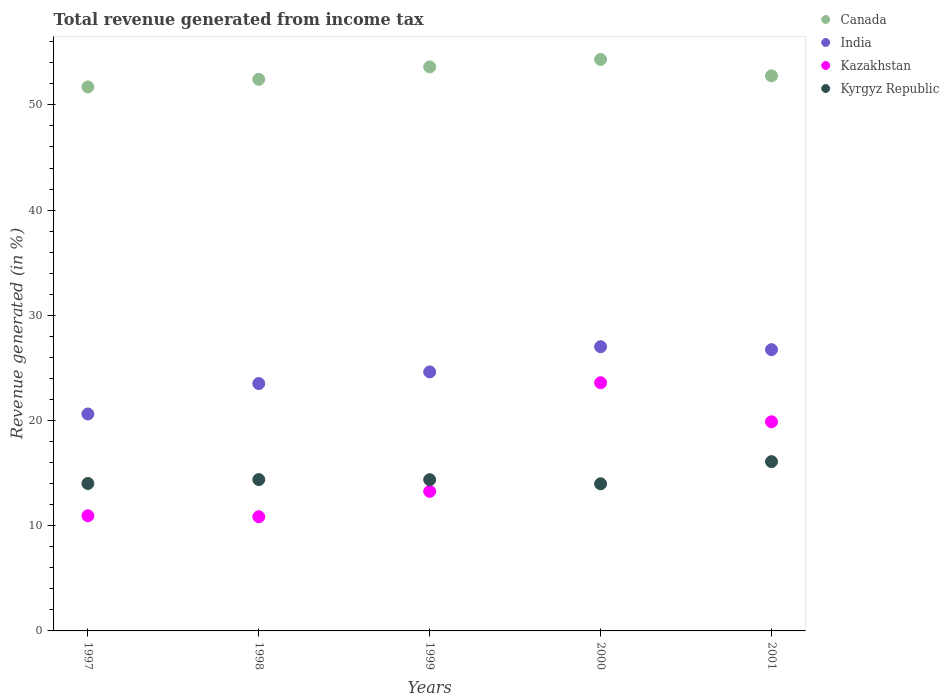How many different coloured dotlines are there?
Your response must be concise. 4. Is the number of dotlines equal to the number of legend labels?
Your answer should be very brief. Yes. What is the total revenue generated in Kazakhstan in 1997?
Provide a succinct answer. 10.95. Across all years, what is the maximum total revenue generated in India?
Offer a terse response. 27.01. Across all years, what is the minimum total revenue generated in Canada?
Your response must be concise. 51.71. In which year was the total revenue generated in Kazakhstan minimum?
Make the answer very short. 1998. What is the total total revenue generated in India in the graph?
Offer a very short reply. 122.5. What is the difference between the total revenue generated in Kyrgyz Republic in 1997 and that in 2001?
Give a very brief answer. -2.08. What is the difference between the total revenue generated in Kyrgyz Republic in 2000 and the total revenue generated in Kazakhstan in 2001?
Your answer should be compact. -5.89. What is the average total revenue generated in Canada per year?
Give a very brief answer. 52.97. In the year 1998, what is the difference between the total revenue generated in India and total revenue generated in Kyrgyz Republic?
Offer a very short reply. 9.13. What is the ratio of the total revenue generated in India in 1997 to that in 1998?
Your response must be concise. 0.88. Is the total revenue generated in Canada in 1997 less than that in 2000?
Keep it short and to the point. Yes. What is the difference between the highest and the second highest total revenue generated in Kyrgyz Republic?
Your answer should be very brief. 1.71. What is the difference between the highest and the lowest total revenue generated in Kazakhstan?
Keep it short and to the point. 12.74. Is the sum of the total revenue generated in India in 1997 and 2001 greater than the maximum total revenue generated in Kazakhstan across all years?
Make the answer very short. Yes. Is it the case that in every year, the sum of the total revenue generated in Kyrgyz Republic and total revenue generated in India  is greater than the total revenue generated in Kazakhstan?
Offer a terse response. Yes. Does the total revenue generated in India monotonically increase over the years?
Give a very brief answer. No. How many dotlines are there?
Your answer should be very brief. 4. What is the difference between two consecutive major ticks on the Y-axis?
Offer a very short reply. 10. Are the values on the major ticks of Y-axis written in scientific E-notation?
Keep it short and to the point. No. Does the graph contain grids?
Give a very brief answer. No. How many legend labels are there?
Ensure brevity in your answer.  4. How are the legend labels stacked?
Your answer should be very brief. Vertical. What is the title of the graph?
Make the answer very short. Total revenue generated from income tax. Does "Sierra Leone" appear as one of the legend labels in the graph?
Keep it short and to the point. No. What is the label or title of the X-axis?
Your answer should be very brief. Years. What is the label or title of the Y-axis?
Keep it short and to the point. Revenue generated (in %). What is the Revenue generated (in %) in Canada in 1997?
Your answer should be very brief. 51.71. What is the Revenue generated (in %) in India in 1997?
Your answer should be very brief. 20.62. What is the Revenue generated (in %) of Kazakhstan in 1997?
Ensure brevity in your answer.  10.95. What is the Revenue generated (in %) in Kyrgyz Republic in 1997?
Make the answer very short. 14.01. What is the Revenue generated (in %) of Canada in 1998?
Give a very brief answer. 52.43. What is the Revenue generated (in %) of India in 1998?
Provide a short and direct response. 23.51. What is the Revenue generated (in %) in Kazakhstan in 1998?
Give a very brief answer. 10.85. What is the Revenue generated (in %) in Kyrgyz Republic in 1998?
Keep it short and to the point. 14.39. What is the Revenue generated (in %) in Canada in 1999?
Provide a succinct answer. 53.61. What is the Revenue generated (in %) of India in 1999?
Make the answer very short. 24.62. What is the Revenue generated (in %) in Kazakhstan in 1999?
Provide a succinct answer. 13.26. What is the Revenue generated (in %) of Kyrgyz Republic in 1999?
Your answer should be compact. 14.38. What is the Revenue generated (in %) of Canada in 2000?
Give a very brief answer. 54.32. What is the Revenue generated (in %) in India in 2000?
Your response must be concise. 27.01. What is the Revenue generated (in %) of Kazakhstan in 2000?
Give a very brief answer. 23.59. What is the Revenue generated (in %) of Kyrgyz Republic in 2000?
Your response must be concise. 13.98. What is the Revenue generated (in %) of Canada in 2001?
Offer a very short reply. 52.76. What is the Revenue generated (in %) of India in 2001?
Make the answer very short. 26.73. What is the Revenue generated (in %) in Kazakhstan in 2001?
Give a very brief answer. 19.88. What is the Revenue generated (in %) of Kyrgyz Republic in 2001?
Provide a short and direct response. 16.09. Across all years, what is the maximum Revenue generated (in %) in Canada?
Your answer should be compact. 54.32. Across all years, what is the maximum Revenue generated (in %) in India?
Your answer should be very brief. 27.01. Across all years, what is the maximum Revenue generated (in %) in Kazakhstan?
Offer a very short reply. 23.59. Across all years, what is the maximum Revenue generated (in %) of Kyrgyz Republic?
Provide a short and direct response. 16.09. Across all years, what is the minimum Revenue generated (in %) in Canada?
Your answer should be compact. 51.71. Across all years, what is the minimum Revenue generated (in %) of India?
Offer a very short reply. 20.62. Across all years, what is the minimum Revenue generated (in %) of Kazakhstan?
Make the answer very short. 10.85. Across all years, what is the minimum Revenue generated (in %) of Kyrgyz Republic?
Your answer should be very brief. 13.98. What is the total Revenue generated (in %) in Canada in the graph?
Give a very brief answer. 264.83. What is the total Revenue generated (in %) of India in the graph?
Give a very brief answer. 122.5. What is the total Revenue generated (in %) of Kazakhstan in the graph?
Provide a succinct answer. 78.53. What is the total Revenue generated (in %) of Kyrgyz Republic in the graph?
Provide a short and direct response. 72.85. What is the difference between the Revenue generated (in %) in Canada in 1997 and that in 1998?
Your answer should be very brief. -0.72. What is the difference between the Revenue generated (in %) in India in 1997 and that in 1998?
Give a very brief answer. -2.89. What is the difference between the Revenue generated (in %) of Kazakhstan in 1997 and that in 1998?
Offer a terse response. 0.09. What is the difference between the Revenue generated (in %) of Kyrgyz Republic in 1997 and that in 1998?
Provide a short and direct response. -0.37. What is the difference between the Revenue generated (in %) in Canada in 1997 and that in 1999?
Provide a short and direct response. -1.9. What is the difference between the Revenue generated (in %) in India in 1997 and that in 1999?
Your answer should be compact. -4. What is the difference between the Revenue generated (in %) of Kazakhstan in 1997 and that in 1999?
Provide a succinct answer. -2.32. What is the difference between the Revenue generated (in %) of Kyrgyz Republic in 1997 and that in 1999?
Offer a terse response. -0.36. What is the difference between the Revenue generated (in %) in Canada in 1997 and that in 2000?
Your response must be concise. -2.61. What is the difference between the Revenue generated (in %) in India in 1997 and that in 2000?
Provide a short and direct response. -6.39. What is the difference between the Revenue generated (in %) of Kazakhstan in 1997 and that in 2000?
Ensure brevity in your answer.  -12.65. What is the difference between the Revenue generated (in %) of Kyrgyz Republic in 1997 and that in 2000?
Make the answer very short. 0.03. What is the difference between the Revenue generated (in %) in Canada in 1997 and that in 2001?
Keep it short and to the point. -1.05. What is the difference between the Revenue generated (in %) of India in 1997 and that in 2001?
Your answer should be very brief. -6.11. What is the difference between the Revenue generated (in %) of Kazakhstan in 1997 and that in 2001?
Your answer should be very brief. -8.93. What is the difference between the Revenue generated (in %) in Kyrgyz Republic in 1997 and that in 2001?
Provide a short and direct response. -2.08. What is the difference between the Revenue generated (in %) of Canada in 1998 and that in 1999?
Your answer should be compact. -1.18. What is the difference between the Revenue generated (in %) of India in 1998 and that in 1999?
Your answer should be compact. -1.11. What is the difference between the Revenue generated (in %) of Kazakhstan in 1998 and that in 1999?
Make the answer very short. -2.41. What is the difference between the Revenue generated (in %) in Kyrgyz Republic in 1998 and that in 1999?
Your answer should be very brief. 0.01. What is the difference between the Revenue generated (in %) of Canada in 1998 and that in 2000?
Your response must be concise. -1.89. What is the difference between the Revenue generated (in %) of India in 1998 and that in 2000?
Provide a short and direct response. -3.5. What is the difference between the Revenue generated (in %) in Kazakhstan in 1998 and that in 2000?
Make the answer very short. -12.74. What is the difference between the Revenue generated (in %) of Kyrgyz Republic in 1998 and that in 2000?
Provide a short and direct response. 0.4. What is the difference between the Revenue generated (in %) of Canada in 1998 and that in 2001?
Offer a terse response. -0.33. What is the difference between the Revenue generated (in %) of India in 1998 and that in 2001?
Make the answer very short. -3.22. What is the difference between the Revenue generated (in %) in Kazakhstan in 1998 and that in 2001?
Your answer should be compact. -9.02. What is the difference between the Revenue generated (in %) in Kyrgyz Republic in 1998 and that in 2001?
Keep it short and to the point. -1.71. What is the difference between the Revenue generated (in %) of Canada in 1999 and that in 2000?
Your answer should be very brief. -0.71. What is the difference between the Revenue generated (in %) of India in 1999 and that in 2000?
Your answer should be compact. -2.4. What is the difference between the Revenue generated (in %) in Kazakhstan in 1999 and that in 2000?
Provide a succinct answer. -10.33. What is the difference between the Revenue generated (in %) of Kyrgyz Republic in 1999 and that in 2000?
Make the answer very short. 0.39. What is the difference between the Revenue generated (in %) in Canada in 1999 and that in 2001?
Provide a short and direct response. 0.85. What is the difference between the Revenue generated (in %) in India in 1999 and that in 2001?
Provide a succinct answer. -2.12. What is the difference between the Revenue generated (in %) in Kazakhstan in 1999 and that in 2001?
Offer a terse response. -6.61. What is the difference between the Revenue generated (in %) in Kyrgyz Republic in 1999 and that in 2001?
Your answer should be very brief. -1.72. What is the difference between the Revenue generated (in %) in Canada in 2000 and that in 2001?
Your answer should be very brief. 1.56. What is the difference between the Revenue generated (in %) in India in 2000 and that in 2001?
Your response must be concise. 0.28. What is the difference between the Revenue generated (in %) in Kazakhstan in 2000 and that in 2001?
Provide a succinct answer. 3.71. What is the difference between the Revenue generated (in %) in Kyrgyz Republic in 2000 and that in 2001?
Provide a succinct answer. -2.11. What is the difference between the Revenue generated (in %) of Canada in 1997 and the Revenue generated (in %) of India in 1998?
Offer a very short reply. 28.2. What is the difference between the Revenue generated (in %) in Canada in 1997 and the Revenue generated (in %) in Kazakhstan in 1998?
Your answer should be very brief. 40.86. What is the difference between the Revenue generated (in %) in Canada in 1997 and the Revenue generated (in %) in Kyrgyz Republic in 1998?
Offer a very short reply. 37.32. What is the difference between the Revenue generated (in %) in India in 1997 and the Revenue generated (in %) in Kazakhstan in 1998?
Keep it short and to the point. 9.77. What is the difference between the Revenue generated (in %) of India in 1997 and the Revenue generated (in %) of Kyrgyz Republic in 1998?
Offer a terse response. 6.24. What is the difference between the Revenue generated (in %) in Kazakhstan in 1997 and the Revenue generated (in %) in Kyrgyz Republic in 1998?
Provide a succinct answer. -3.44. What is the difference between the Revenue generated (in %) of Canada in 1997 and the Revenue generated (in %) of India in 1999?
Make the answer very short. 27.09. What is the difference between the Revenue generated (in %) in Canada in 1997 and the Revenue generated (in %) in Kazakhstan in 1999?
Make the answer very short. 38.44. What is the difference between the Revenue generated (in %) in Canada in 1997 and the Revenue generated (in %) in Kyrgyz Republic in 1999?
Provide a short and direct response. 37.33. What is the difference between the Revenue generated (in %) in India in 1997 and the Revenue generated (in %) in Kazakhstan in 1999?
Provide a succinct answer. 7.36. What is the difference between the Revenue generated (in %) of India in 1997 and the Revenue generated (in %) of Kyrgyz Republic in 1999?
Provide a succinct answer. 6.25. What is the difference between the Revenue generated (in %) in Kazakhstan in 1997 and the Revenue generated (in %) in Kyrgyz Republic in 1999?
Your answer should be very brief. -3.43. What is the difference between the Revenue generated (in %) of Canada in 1997 and the Revenue generated (in %) of India in 2000?
Offer a terse response. 24.7. What is the difference between the Revenue generated (in %) in Canada in 1997 and the Revenue generated (in %) in Kazakhstan in 2000?
Your answer should be compact. 28.12. What is the difference between the Revenue generated (in %) of Canada in 1997 and the Revenue generated (in %) of Kyrgyz Republic in 2000?
Offer a terse response. 37.73. What is the difference between the Revenue generated (in %) in India in 1997 and the Revenue generated (in %) in Kazakhstan in 2000?
Ensure brevity in your answer.  -2.97. What is the difference between the Revenue generated (in %) in India in 1997 and the Revenue generated (in %) in Kyrgyz Republic in 2000?
Make the answer very short. 6.64. What is the difference between the Revenue generated (in %) in Kazakhstan in 1997 and the Revenue generated (in %) in Kyrgyz Republic in 2000?
Provide a succinct answer. -3.04. What is the difference between the Revenue generated (in %) of Canada in 1997 and the Revenue generated (in %) of India in 2001?
Provide a succinct answer. 24.98. What is the difference between the Revenue generated (in %) of Canada in 1997 and the Revenue generated (in %) of Kazakhstan in 2001?
Ensure brevity in your answer.  31.83. What is the difference between the Revenue generated (in %) in Canada in 1997 and the Revenue generated (in %) in Kyrgyz Republic in 2001?
Offer a terse response. 35.62. What is the difference between the Revenue generated (in %) of India in 1997 and the Revenue generated (in %) of Kazakhstan in 2001?
Make the answer very short. 0.74. What is the difference between the Revenue generated (in %) of India in 1997 and the Revenue generated (in %) of Kyrgyz Republic in 2001?
Provide a short and direct response. 4.53. What is the difference between the Revenue generated (in %) of Kazakhstan in 1997 and the Revenue generated (in %) of Kyrgyz Republic in 2001?
Provide a succinct answer. -5.14. What is the difference between the Revenue generated (in %) of Canada in 1998 and the Revenue generated (in %) of India in 1999?
Offer a terse response. 27.81. What is the difference between the Revenue generated (in %) in Canada in 1998 and the Revenue generated (in %) in Kazakhstan in 1999?
Your response must be concise. 39.17. What is the difference between the Revenue generated (in %) of Canada in 1998 and the Revenue generated (in %) of Kyrgyz Republic in 1999?
Give a very brief answer. 38.06. What is the difference between the Revenue generated (in %) in India in 1998 and the Revenue generated (in %) in Kazakhstan in 1999?
Your response must be concise. 10.25. What is the difference between the Revenue generated (in %) in India in 1998 and the Revenue generated (in %) in Kyrgyz Republic in 1999?
Give a very brief answer. 9.14. What is the difference between the Revenue generated (in %) in Kazakhstan in 1998 and the Revenue generated (in %) in Kyrgyz Republic in 1999?
Make the answer very short. -3.52. What is the difference between the Revenue generated (in %) in Canada in 1998 and the Revenue generated (in %) in India in 2000?
Provide a short and direct response. 25.42. What is the difference between the Revenue generated (in %) in Canada in 1998 and the Revenue generated (in %) in Kazakhstan in 2000?
Offer a very short reply. 28.84. What is the difference between the Revenue generated (in %) in Canada in 1998 and the Revenue generated (in %) in Kyrgyz Republic in 2000?
Provide a short and direct response. 38.45. What is the difference between the Revenue generated (in %) of India in 1998 and the Revenue generated (in %) of Kazakhstan in 2000?
Provide a succinct answer. -0.08. What is the difference between the Revenue generated (in %) in India in 1998 and the Revenue generated (in %) in Kyrgyz Republic in 2000?
Give a very brief answer. 9.53. What is the difference between the Revenue generated (in %) of Kazakhstan in 1998 and the Revenue generated (in %) of Kyrgyz Republic in 2000?
Provide a short and direct response. -3.13. What is the difference between the Revenue generated (in %) in Canada in 1998 and the Revenue generated (in %) in India in 2001?
Make the answer very short. 25.7. What is the difference between the Revenue generated (in %) of Canada in 1998 and the Revenue generated (in %) of Kazakhstan in 2001?
Give a very brief answer. 32.55. What is the difference between the Revenue generated (in %) in Canada in 1998 and the Revenue generated (in %) in Kyrgyz Republic in 2001?
Your answer should be compact. 36.34. What is the difference between the Revenue generated (in %) of India in 1998 and the Revenue generated (in %) of Kazakhstan in 2001?
Provide a short and direct response. 3.64. What is the difference between the Revenue generated (in %) of India in 1998 and the Revenue generated (in %) of Kyrgyz Republic in 2001?
Your answer should be very brief. 7.42. What is the difference between the Revenue generated (in %) of Kazakhstan in 1998 and the Revenue generated (in %) of Kyrgyz Republic in 2001?
Give a very brief answer. -5.24. What is the difference between the Revenue generated (in %) in Canada in 1999 and the Revenue generated (in %) in India in 2000?
Keep it short and to the point. 26.6. What is the difference between the Revenue generated (in %) of Canada in 1999 and the Revenue generated (in %) of Kazakhstan in 2000?
Keep it short and to the point. 30.02. What is the difference between the Revenue generated (in %) of Canada in 1999 and the Revenue generated (in %) of Kyrgyz Republic in 2000?
Offer a very short reply. 39.63. What is the difference between the Revenue generated (in %) in India in 1999 and the Revenue generated (in %) in Kazakhstan in 2000?
Keep it short and to the point. 1.03. What is the difference between the Revenue generated (in %) of India in 1999 and the Revenue generated (in %) of Kyrgyz Republic in 2000?
Give a very brief answer. 10.63. What is the difference between the Revenue generated (in %) of Kazakhstan in 1999 and the Revenue generated (in %) of Kyrgyz Republic in 2000?
Your answer should be compact. -0.72. What is the difference between the Revenue generated (in %) in Canada in 1999 and the Revenue generated (in %) in India in 2001?
Your answer should be compact. 26.88. What is the difference between the Revenue generated (in %) of Canada in 1999 and the Revenue generated (in %) of Kazakhstan in 2001?
Offer a very short reply. 33.73. What is the difference between the Revenue generated (in %) of Canada in 1999 and the Revenue generated (in %) of Kyrgyz Republic in 2001?
Offer a very short reply. 37.52. What is the difference between the Revenue generated (in %) of India in 1999 and the Revenue generated (in %) of Kazakhstan in 2001?
Ensure brevity in your answer.  4.74. What is the difference between the Revenue generated (in %) of India in 1999 and the Revenue generated (in %) of Kyrgyz Republic in 2001?
Give a very brief answer. 8.53. What is the difference between the Revenue generated (in %) of Kazakhstan in 1999 and the Revenue generated (in %) of Kyrgyz Republic in 2001?
Ensure brevity in your answer.  -2.83. What is the difference between the Revenue generated (in %) of Canada in 2000 and the Revenue generated (in %) of India in 2001?
Ensure brevity in your answer.  27.59. What is the difference between the Revenue generated (in %) of Canada in 2000 and the Revenue generated (in %) of Kazakhstan in 2001?
Your response must be concise. 34.44. What is the difference between the Revenue generated (in %) of Canada in 2000 and the Revenue generated (in %) of Kyrgyz Republic in 2001?
Keep it short and to the point. 38.23. What is the difference between the Revenue generated (in %) of India in 2000 and the Revenue generated (in %) of Kazakhstan in 2001?
Offer a terse response. 7.14. What is the difference between the Revenue generated (in %) of India in 2000 and the Revenue generated (in %) of Kyrgyz Republic in 2001?
Provide a succinct answer. 10.92. What is the difference between the Revenue generated (in %) in Kazakhstan in 2000 and the Revenue generated (in %) in Kyrgyz Republic in 2001?
Make the answer very short. 7.5. What is the average Revenue generated (in %) of Canada per year?
Your response must be concise. 52.97. What is the average Revenue generated (in %) of India per year?
Offer a very short reply. 24.5. What is the average Revenue generated (in %) in Kazakhstan per year?
Your answer should be very brief. 15.71. What is the average Revenue generated (in %) in Kyrgyz Republic per year?
Offer a very short reply. 14.57. In the year 1997, what is the difference between the Revenue generated (in %) in Canada and Revenue generated (in %) in India?
Ensure brevity in your answer.  31.09. In the year 1997, what is the difference between the Revenue generated (in %) in Canada and Revenue generated (in %) in Kazakhstan?
Offer a very short reply. 40.76. In the year 1997, what is the difference between the Revenue generated (in %) in Canada and Revenue generated (in %) in Kyrgyz Republic?
Ensure brevity in your answer.  37.7. In the year 1997, what is the difference between the Revenue generated (in %) of India and Revenue generated (in %) of Kazakhstan?
Make the answer very short. 9.68. In the year 1997, what is the difference between the Revenue generated (in %) of India and Revenue generated (in %) of Kyrgyz Republic?
Provide a short and direct response. 6.61. In the year 1997, what is the difference between the Revenue generated (in %) of Kazakhstan and Revenue generated (in %) of Kyrgyz Republic?
Offer a very short reply. -3.07. In the year 1998, what is the difference between the Revenue generated (in %) in Canada and Revenue generated (in %) in India?
Provide a short and direct response. 28.92. In the year 1998, what is the difference between the Revenue generated (in %) of Canada and Revenue generated (in %) of Kazakhstan?
Keep it short and to the point. 41.58. In the year 1998, what is the difference between the Revenue generated (in %) of Canada and Revenue generated (in %) of Kyrgyz Republic?
Offer a very short reply. 38.05. In the year 1998, what is the difference between the Revenue generated (in %) in India and Revenue generated (in %) in Kazakhstan?
Make the answer very short. 12.66. In the year 1998, what is the difference between the Revenue generated (in %) of India and Revenue generated (in %) of Kyrgyz Republic?
Provide a short and direct response. 9.13. In the year 1998, what is the difference between the Revenue generated (in %) in Kazakhstan and Revenue generated (in %) in Kyrgyz Republic?
Provide a short and direct response. -3.53. In the year 1999, what is the difference between the Revenue generated (in %) in Canada and Revenue generated (in %) in India?
Provide a succinct answer. 28.99. In the year 1999, what is the difference between the Revenue generated (in %) of Canada and Revenue generated (in %) of Kazakhstan?
Make the answer very short. 40.35. In the year 1999, what is the difference between the Revenue generated (in %) in Canada and Revenue generated (in %) in Kyrgyz Republic?
Offer a terse response. 39.24. In the year 1999, what is the difference between the Revenue generated (in %) in India and Revenue generated (in %) in Kazakhstan?
Offer a terse response. 11.35. In the year 1999, what is the difference between the Revenue generated (in %) of India and Revenue generated (in %) of Kyrgyz Republic?
Provide a succinct answer. 10.24. In the year 1999, what is the difference between the Revenue generated (in %) in Kazakhstan and Revenue generated (in %) in Kyrgyz Republic?
Provide a succinct answer. -1.11. In the year 2000, what is the difference between the Revenue generated (in %) of Canada and Revenue generated (in %) of India?
Offer a very short reply. 27.31. In the year 2000, what is the difference between the Revenue generated (in %) in Canada and Revenue generated (in %) in Kazakhstan?
Ensure brevity in your answer.  30.73. In the year 2000, what is the difference between the Revenue generated (in %) in Canada and Revenue generated (in %) in Kyrgyz Republic?
Your response must be concise. 40.34. In the year 2000, what is the difference between the Revenue generated (in %) of India and Revenue generated (in %) of Kazakhstan?
Your answer should be very brief. 3.42. In the year 2000, what is the difference between the Revenue generated (in %) in India and Revenue generated (in %) in Kyrgyz Republic?
Your answer should be compact. 13.03. In the year 2000, what is the difference between the Revenue generated (in %) in Kazakhstan and Revenue generated (in %) in Kyrgyz Republic?
Keep it short and to the point. 9.61. In the year 2001, what is the difference between the Revenue generated (in %) in Canada and Revenue generated (in %) in India?
Offer a very short reply. 26.03. In the year 2001, what is the difference between the Revenue generated (in %) of Canada and Revenue generated (in %) of Kazakhstan?
Provide a short and direct response. 32.88. In the year 2001, what is the difference between the Revenue generated (in %) in Canada and Revenue generated (in %) in Kyrgyz Republic?
Provide a succinct answer. 36.67. In the year 2001, what is the difference between the Revenue generated (in %) in India and Revenue generated (in %) in Kazakhstan?
Keep it short and to the point. 6.86. In the year 2001, what is the difference between the Revenue generated (in %) of India and Revenue generated (in %) of Kyrgyz Republic?
Your answer should be very brief. 10.64. In the year 2001, what is the difference between the Revenue generated (in %) in Kazakhstan and Revenue generated (in %) in Kyrgyz Republic?
Ensure brevity in your answer.  3.79. What is the ratio of the Revenue generated (in %) of Canada in 1997 to that in 1998?
Offer a very short reply. 0.99. What is the ratio of the Revenue generated (in %) of India in 1997 to that in 1998?
Your answer should be compact. 0.88. What is the ratio of the Revenue generated (in %) in Kazakhstan in 1997 to that in 1998?
Keep it short and to the point. 1.01. What is the ratio of the Revenue generated (in %) of Kyrgyz Republic in 1997 to that in 1998?
Your answer should be very brief. 0.97. What is the ratio of the Revenue generated (in %) of Canada in 1997 to that in 1999?
Ensure brevity in your answer.  0.96. What is the ratio of the Revenue generated (in %) of India in 1997 to that in 1999?
Keep it short and to the point. 0.84. What is the ratio of the Revenue generated (in %) of Kazakhstan in 1997 to that in 1999?
Your answer should be compact. 0.83. What is the ratio of the Revenue generated (in %) of Kyrgyz Republic in 1997 to that in 1999?
Provide a short and direct response. 0.97. What is the ratio of the Revenue generated (in %) in Canada in 1997 to that in 2000?
Your answer should be compact. 0.95. What is the ratio of the Revenue generated (in %) in India in 1997 to that in 2000?
Offer a terse response. 0.76. What is the ratio of the Revenue generated (in %) of Kazakhstan in 1997 to that in 2000?
Give a very brief answer. 0.46. What is the ratio of the Revenue generated (in %) of Kyrgyz Republic in 1997 to that in 2000?
Give a very brief answer. 1. What is the ratio of the Revenue generated (in %) in Canada in 1997 to that in 2001?
Your response must be concise. 0.98. What is the ratio of the Revenue generated (in %) of India in 1997 to that in 2001?
Provide a succinct answer. 0.77. What is the ratio of the Revenue generated (in %) of Kazakhstan in 1997 to that in 2001?
Ensure brevity in your answer.  0.55. What is the ratio of the Revenue generated (in %) in Kyrgyz Republic in 1997 to that in 2001?
Offer a very short reply. 0.87. What is the ratio of the Revenue generated (in %) of Canada in 1998 to that in 1999?
Ensure brevity in your answer.  0.98. What is the ratio of the Revenue generated (in %) of India in 1998 to that in 1999?
Give a very brief answer. 0.96. What is the ratio of the Revenue generated (in %) in Kazakhstan in 1998 to that in 1999?
Your answer should be very brief. 0.82. What is the ratio of the Revenue generated (in %) in Kyrgyz Republic in 1998 to that in 1999?
Provide a short and direct response. 1. What is the ratio of the Revenue generated (in %) of Canada in 1998 to that in 2000?
Keep it short and to the point. 0.97. What is the ratio of the Revenue generated (in %) of India in 1998 to that in 2000?
Give a very brief answer. 0.87. What is the ratio of the Revenue generated (in %) of Kazakhstan in 1998 to that in 2000?
Your answer should be very brief. 0.46. What is the ratio of the Revenue generated (in %) of Kyrgyz Republic in 1998 to that in 2000?
Keep it short and to the point. 1.03. What is the ratio of the Revenue generated (in %) of India in 1998 to that in 2001?
Ensure brevity in your answer.  0.88. What is the ratio of the Revenue generated (in %) in Kazakhstan in 1998 to that in 2001?
Offer a very short reply. 0.55. What is the ratio of the Revenue generated (in %) in Kyrgyz Republic in 1998 to that in 2001?
Offer a very short reply. 0.89. What is the ratio of the Revenue generated (in %) of Canada in 1999 to that in 2000?
Your response must be concise. 0.99. What is the ratio of the Revenue generated (in %) of India in 1999 to that in 2000?
Provide a succinct answer. 0.91. What is the ratio of the Revenue generated (in %) of Kazakhstan in 1999 to that in 2000?
Your response must be concise. 0.56. What is the ratio of the Revenue generated (in %) in Kyrgyz Republic in 1999 to that in 2000?
Provide a short and direct response. 1.03. What is the ratio of the Revenue generated (in %) in Canada in 1999 to that in 2001?
Your response must be concise. 1.02. What is the ratio of the Revenue generated (in %) of India in 1999 to that in 2001?
Keep it short and to the point. 0.92. What is the ratio of the Revenue generated (in %) in Kazakhstan in 1999 to that in 2001?
Ensure brevity in your answer.  0.67. What is the ratio of the Revenue generated (in %) in Kyrgyz Republic in 1999 to that in 2001?
Provide a short and direct response. 0.89. What is the ratio of the Revenue generated (in %) in Canada in 2000 to that in 2001?
Provide a succinct answer. 1.03. What is the ratio of the Revenue generated (in %) in India in 2000 to that in 2001?
Keep it short and to the point. 1.01. What is the ratio of the Revenue generated (in %) of Kazakhstan in 2000 to that in 2001?
Keep it short and to the point. 1.19. What is the ratio of the Revenue generated (in %) of Kyrgyz Republic in 2000 to that in 2001?
Your answer should be very brief. 0.87. What is the difference between the highest and the second highest Revenue generated (in %) of Canada?
Provide a succinct answer. 0.71. What is the difference between the highest and the second highest Revenue generated (in %) in India?
Your answer should be compact. 0.28. What is the difference between the highest and the second highest Revenue generated (in %) of Kazakhstan?
Provide a succinct answer. 3.71. What is the difference between the highest and the second highest Revenue generated (in %) in Kyrgyz Republic?
Keep it short and to the point. 1.71. What is the difference between the highest and the lowest Revenue generated (in %) in Canada?
Provide a succinct answer. 2.61. What is the difference between the highest and the lowest Revenue generated (in %) of India?
Give a very brief answer. 6.39. What is the difference between the highest and the lowest Revenue generated (in %) of Kazakhstan?
Provide a succinct answer. 12.74. What is the difference between the highest and the lowest Revenue generated (in %) of Kyrgyz Republic?
Ensure brevity in your answer.  2.11. 